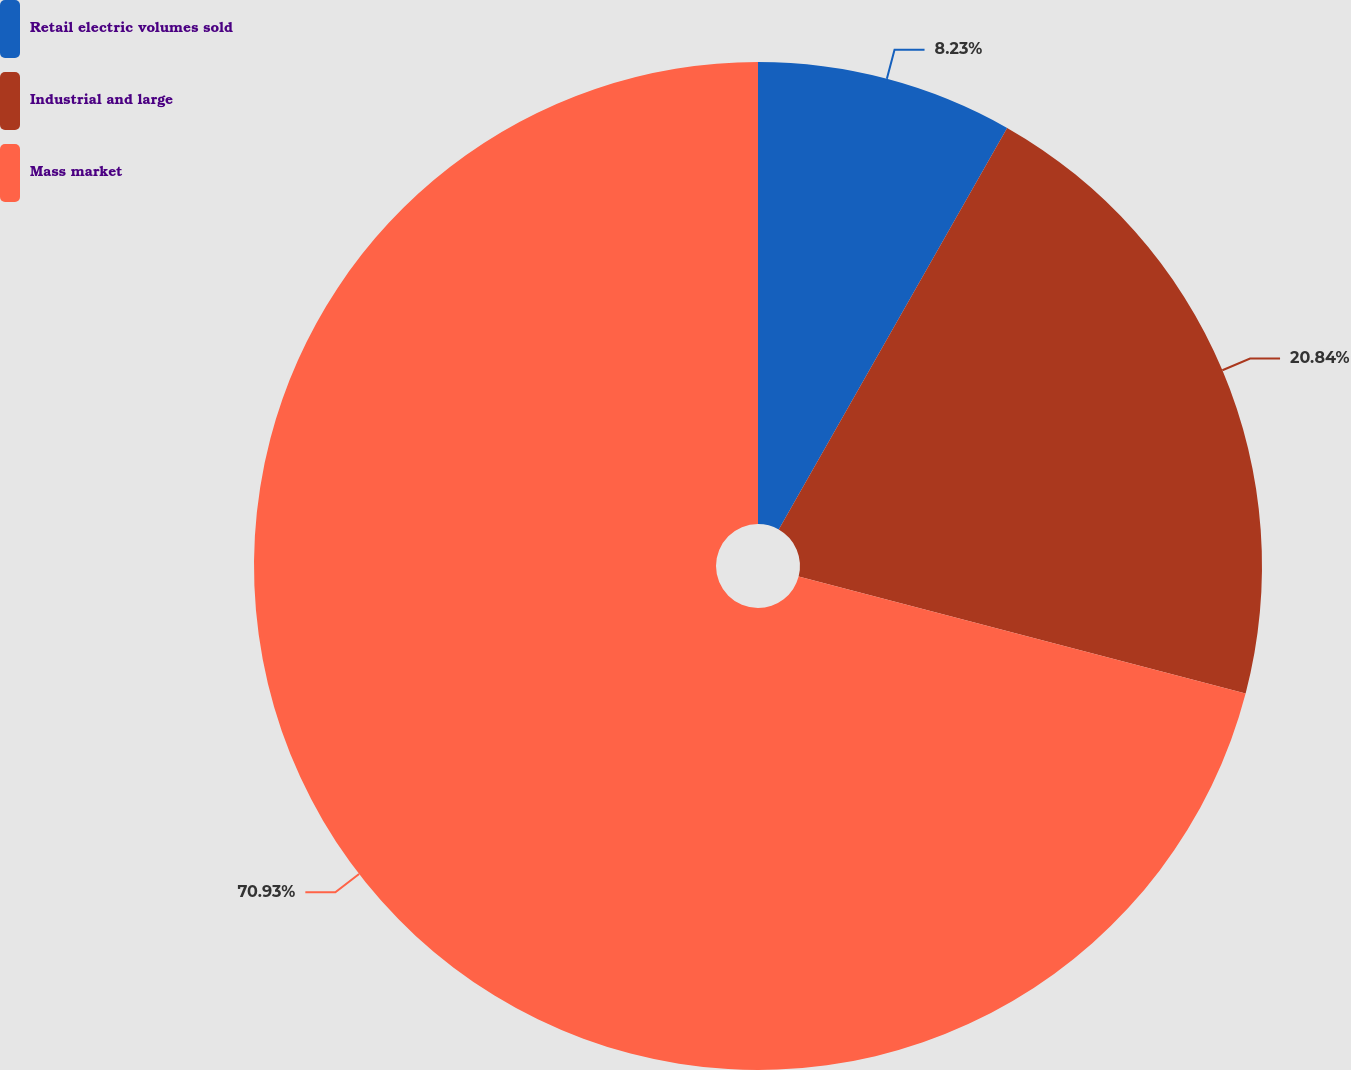Convert chart. <chart><loc_0><loc_0><loc_500><loc_500><pie_chart><fcel>Retail electric volumes sold<fcel>Industrial and large<fcel>Mass market<nl><fcel>8.23%<fcel>20.84%<fcel>70.93%<nl></chart> 